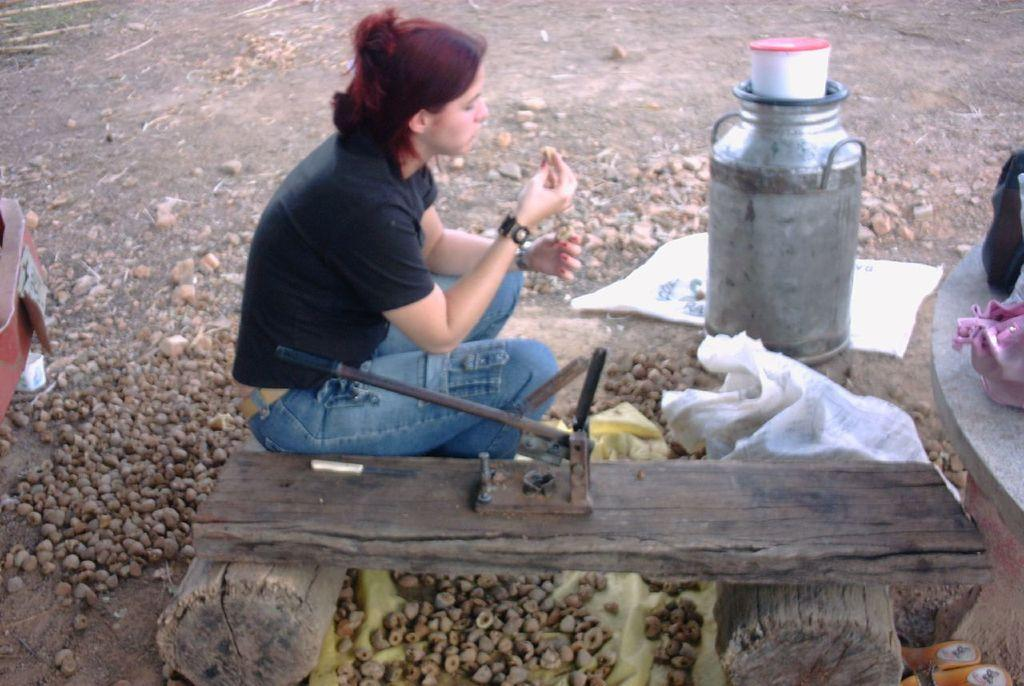What is the main subject of the image? There is a beautiful girl in the image. What is the girl doing in the image? The girl is sitting on a log. What is the girl wearing in the image? The girl is wearing a black color shirt and blue color jeans trouser. What can be seen on the right side of the image? There is an iron can on the right side of the image. How many bombs are visible in the image? There are no bombs present in the image. What type of spiders can be seen crawling on the girl's shirt? There are no spiders visible in the image. 